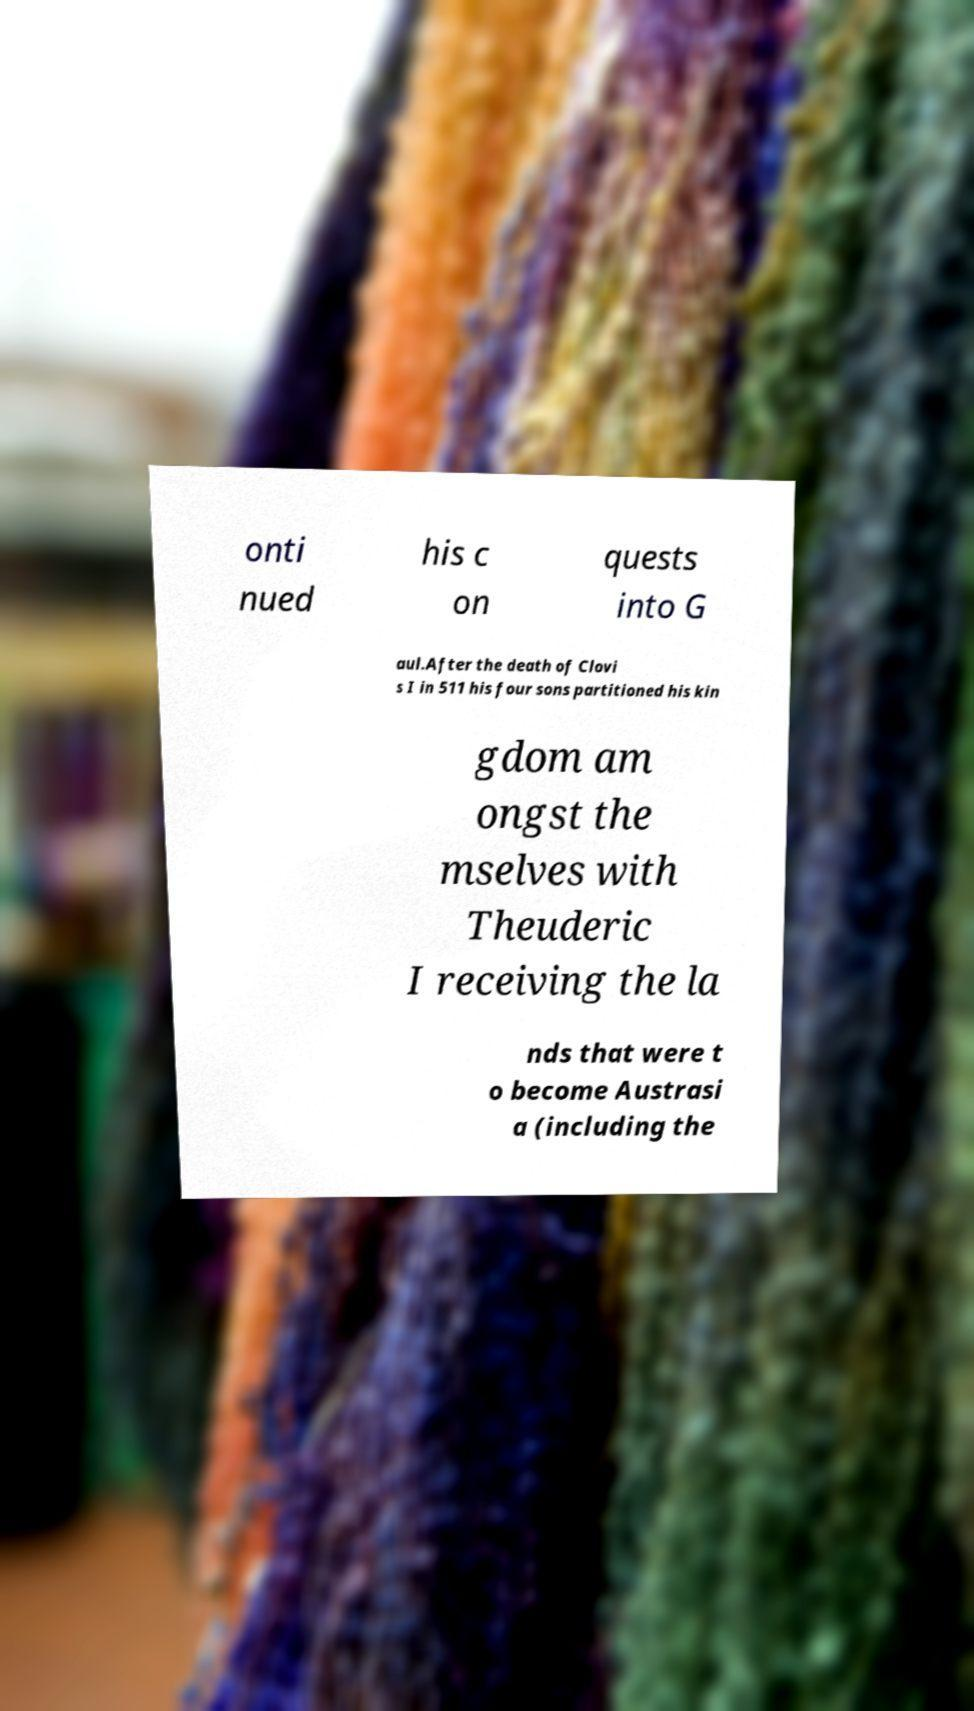For documentation purposes, I need the text within this image transcribed. Could you provide that? onti nued his c on quests into G aul.After the death of Clovi s I in 511 his four sons partitioned his kin gdom am ongst the mselves with Theuderic I receiving the la nds that were t o become Austrasi a (including the 